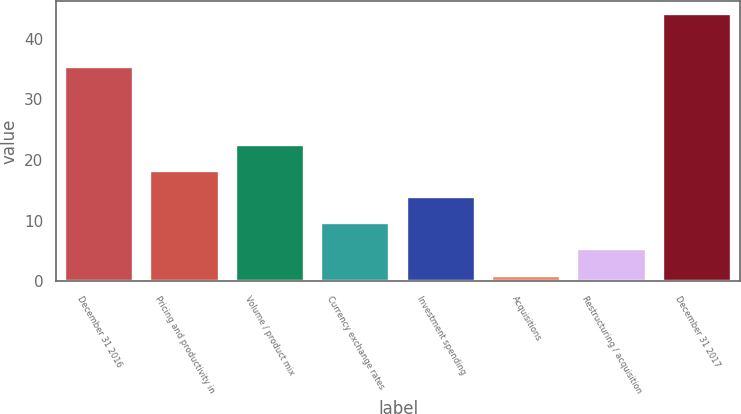<chart> <loc_0><loc_0><loc_500><loc_500><bar_chart><fcel>December 31 2016<fcel>Pricing and productivity in<fcel>Volume / product mix<fcel>Currency exchange rates<fcel>Investment spending<fcel>Acquisitions<fcel>Restructuring / acquisition<fcel>December 31 2017<nl><fcel>35.3<fcel>18.18<fcel>22.5<fcel>9.54<fcel>13.86<fcel>0.9<fcel>5.22<fcel>44.1<nl></chart> 